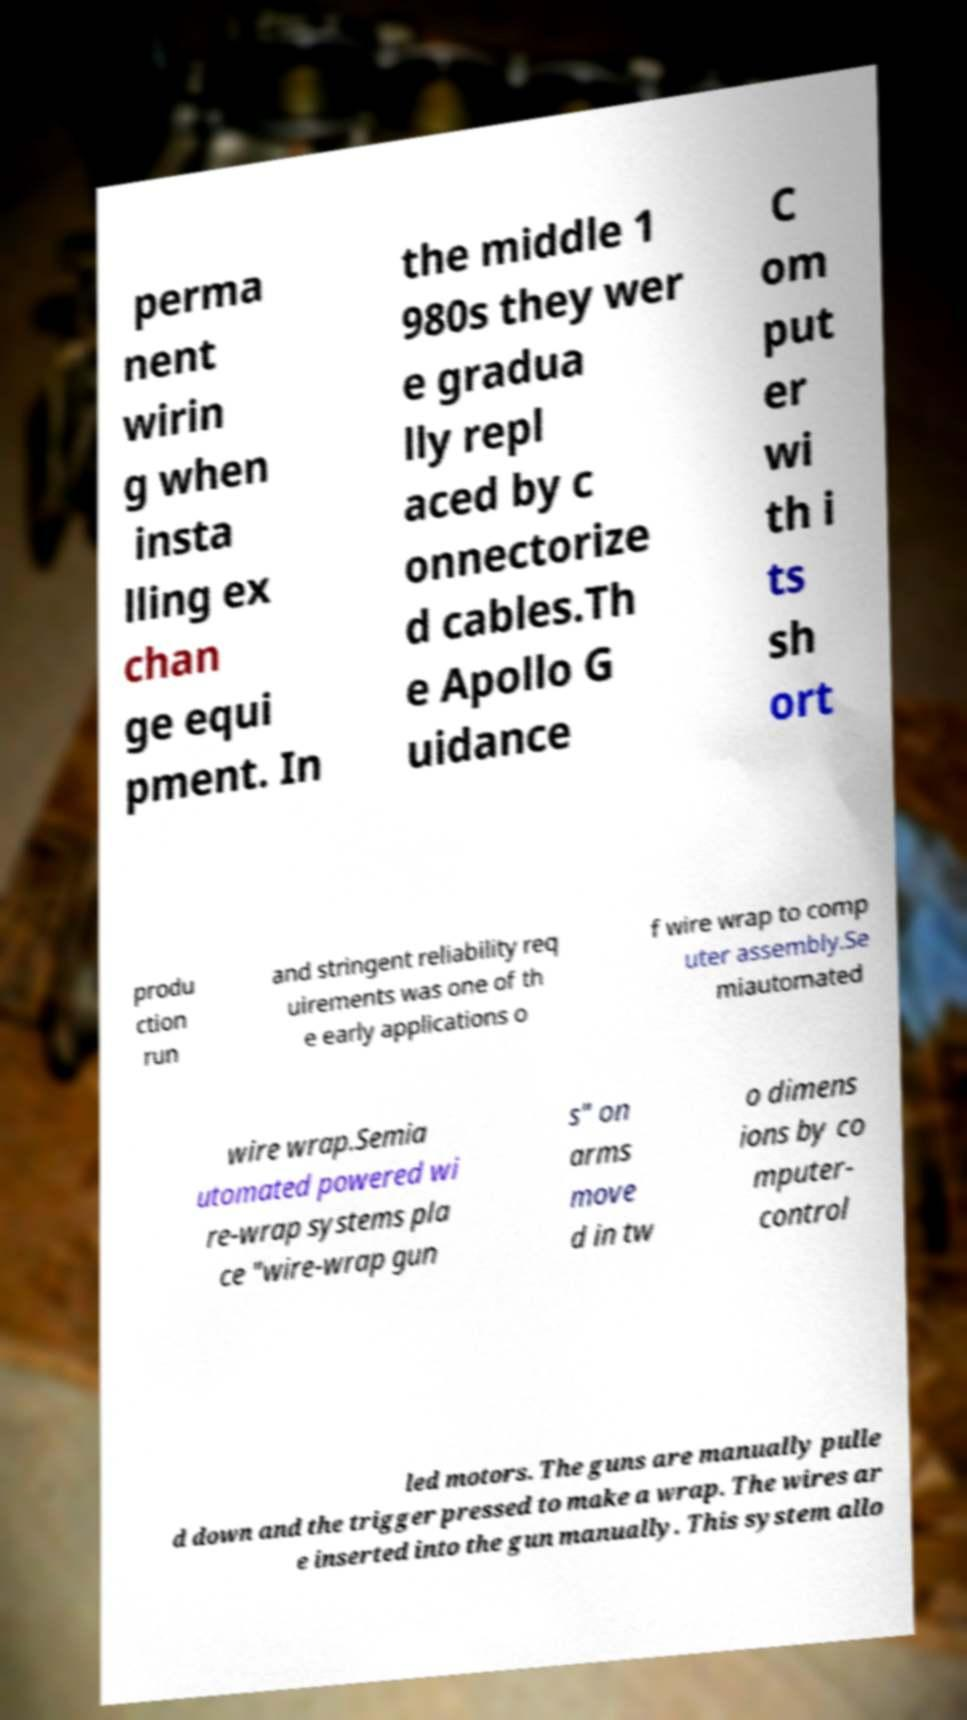For documentation purposes, I need the text within this image transcribed. Could you provide that? perma nent wirin g when insta lling ex chan ge equi pment. In the middle 1 980s they wer e gradua lly repl aced by c onnectorize d cables.Th e Apollo G uidance C om put er wi th i ts sh ort produ ction run and stringent reliability req uirements was one of th e early applications o f wire wrap to comp uter assembly.Se miautomated wire wrap.Semia utomated powered wi re-wrap systems pla ce "wire-wrap gun s" on arms move d in tw o dimens ions by co mputer- control led motors. The guns are manually pulle d down and the trigger pressed to make a wrap. The wires ar e inserted into the gun manually. This system allo 